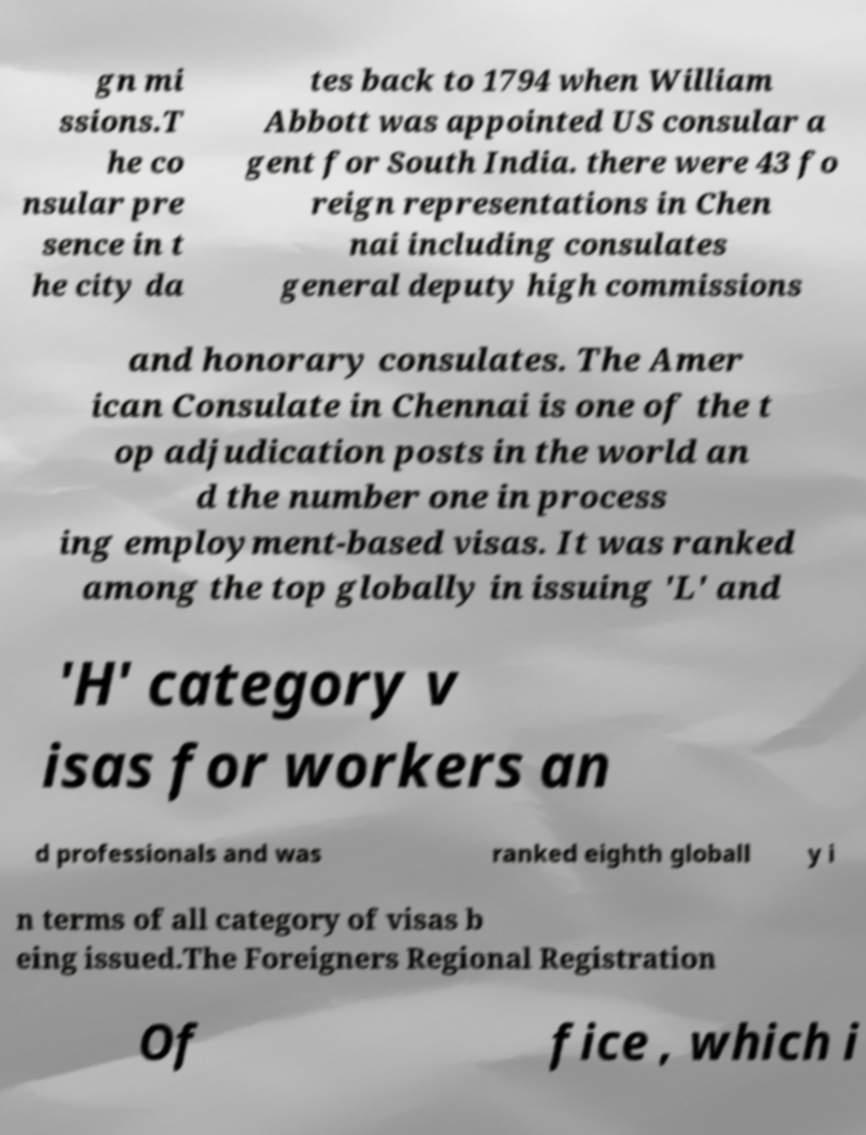What messages or text are displayed in this image? I need them in a readable, typed format. gn mi ssions.T he co nsular pre sence in t he city da tes back to 1794 when William Abbott was appointed US consular a gent for South India. there were 43 fo reign representations in Chen nai including consulates general deputy high commissions and honorary consulates. The Amer ican Consulate in Chennai is one of the t op adjudication posts in the world an d the number one in process ing employment-based visas. It was ranked among the top globally in issuing 'L' and 'H' category v isas for workers an d professionals and was ranked eighth globall y i n terms of all category of visas b eing issued.The Foreigners Regional Registration Of fice , which i 